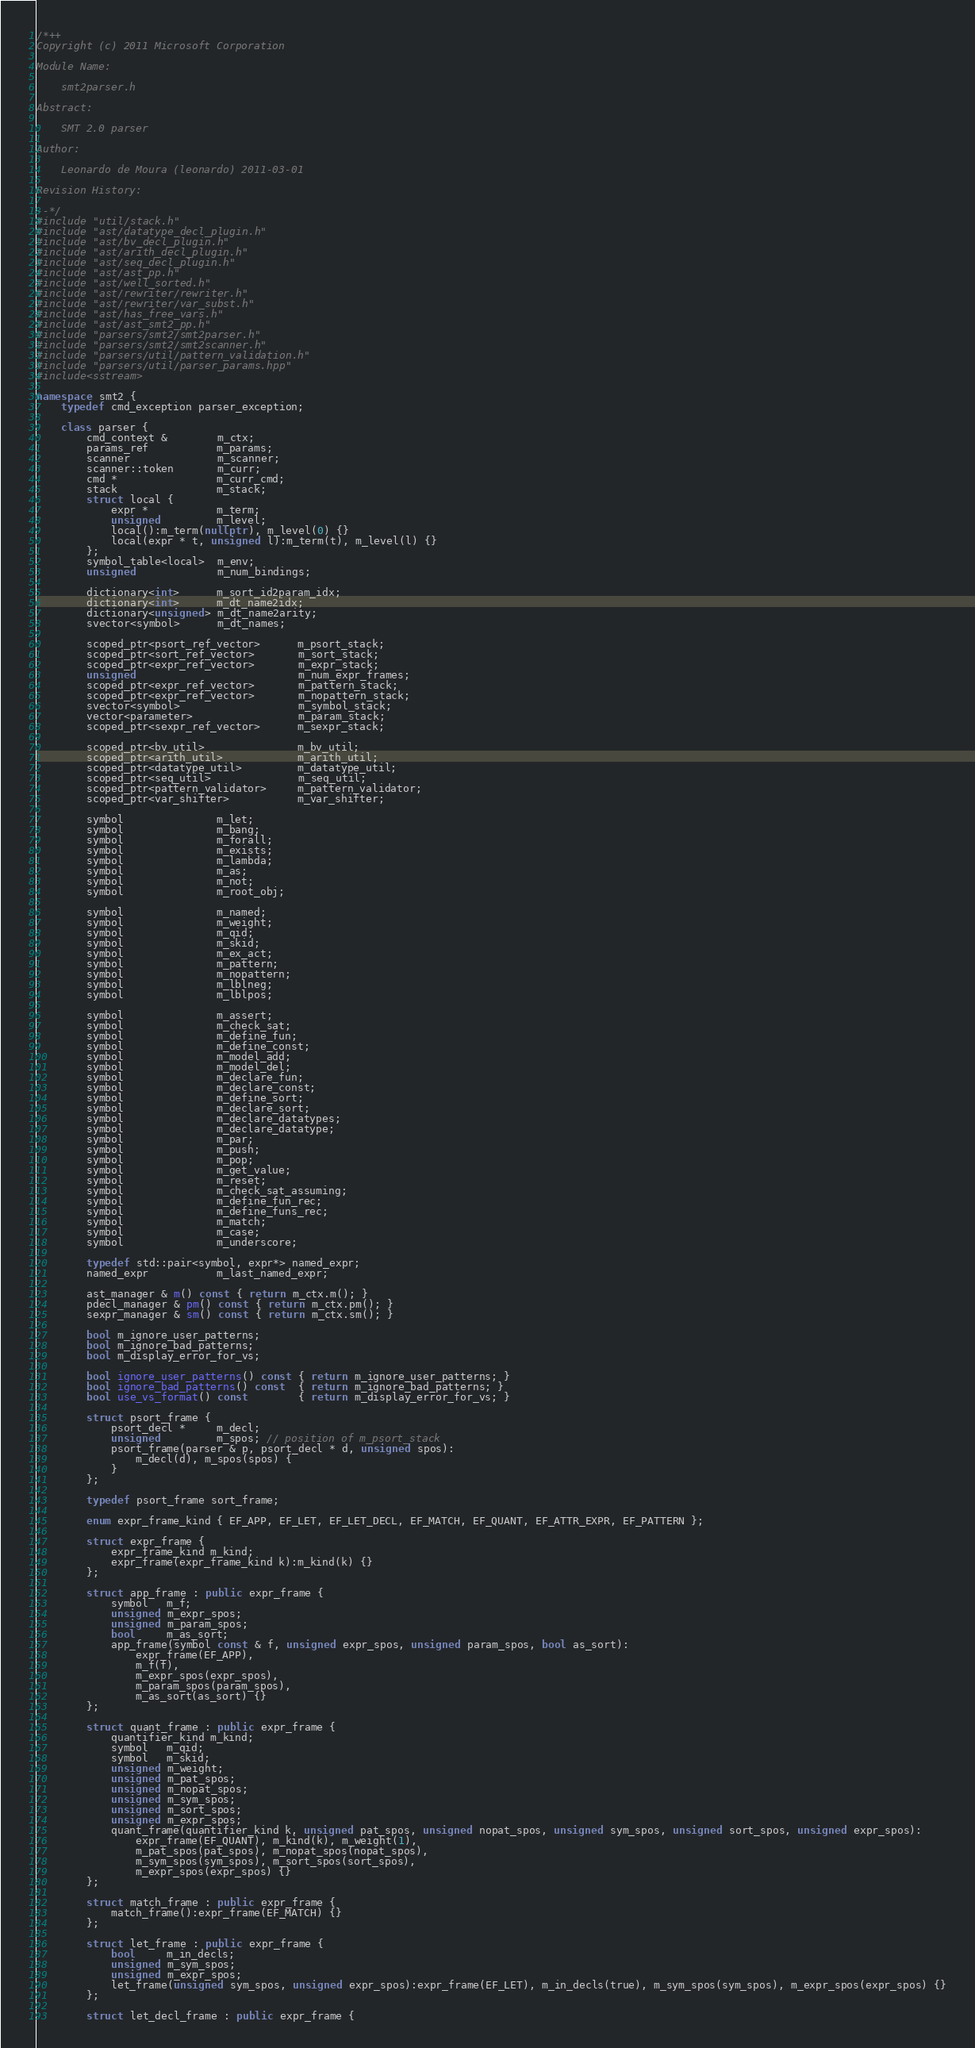Convert code to text. <code><loc_0><loc_0><loc_500><loc_500><_C++_>/*++
Copyright (c) 2011 Microsoft Corporation

Module Name:

    smt2parser.h

Abstract:

    SMT 2.0 parser

Author:

    Leonardo de Moura (leonardo) 2011-03-01

Revision History:

--*/
#include "util/stack.h"
#include "ast/datatype_decl_plugin.h"
#include "ast/bv_decl_plugin.h"
#include "ast/arith_decl_plugin.h"
#include "ast/seq_decl_plugin.h"
#include "ast/ast_pp.h"
#include "ast/well_sorted.h"
#include "ast/rewriter/rewriter.h"
#include "ast/rewriter/var_subst.h"
#include "ast/has_free_vars.h"
#include "ast/ast_smt2_pp.h"
#include "parsers/smt2/smt2parser.h"
#include "parsers/smt2/smt2scanner.h"
#include "parsers/util/pattern_validation.h"
#include "parsers/util/parser_params.hpp"
#include<sstream>

namespace smt2 {
    typedef cmd_exception parser_exception;

    class parser {
        cmd_context &        m_ctx;
        params_ref           m_params;
        scanner              m_scanner;
        scanner::token       m_curr;
        cmd *                m_curr_cmd;
        stack                m_stack;
        struct local {
            expr *           m_term;
            unsigned         m_level;
            local():m_term(nullptr), m_level(0) {}
            local(expr * t, unsigned l):m_term(t), m_level(l) {}
        };
        symbol_table<local>  m_env;
        unsigned             m_num_bindings;

        dictionary<int>      m_sort_id2param_idx;
        dictionary<int>      m_dt_name2idx;
        dictionary<unsigned> m_dt_name2arity;
        svector<symbol>      m_dt_names;

        scoped_ptr<psort_ref_vector>      m_psort_stack;
        scoped_ptr<sort_ref_vector>       m_sort_stack;
        scoped_ptr<expr_ref_vector>       m_expr_stack;
        unsigned                          m_num_expr_frames;
        scoped_ptr<expr_ref_vector>       m_pattern_stack;
        scoped_ptr<expr_ref_vector>       m_nopattern_stack;
        svector<symbol>                   m_symbol_stack;
        vector<parameter>                 m_param_stack;
        scoped_ptr<sexpr_ref_vector>      m_sexpr_stack;

        scoped_ptr<bv_util>               m_bv_util;
        scoped_ptr<arith_util>            m_arith_util;
        scoped_ptr<datatype_util>         m_datatype_util;
        scoped_ptr<seq_util>              m_seq_util;      
        scoped_ptr<pattern_validator>     m_pattern_validator;
        scoped_ptr<var_shifter>           m_var_shifter;

        symbol               m_let;
        symbol               m_bang;
        symbol               m_forall;
        symbol               m_exists;
        symbol               m_lambda;
        symbol               m_as;
        symbol               m_not;
        symbol               m_root_obj;

        symbol               m_named;
        symbol               m_weight;
        symbol               m_qid;
        symbol               m_skid;
        symbol               m_ex_act;
        symbol               m_pattern;
        symbol               m_nopattern;
        symbol               m_lblneg;
        symbol               m_lblpos;

        symbol               m_assert;
        symbol               m_check_sat;
        symbol               m_define_fun;
        symbol               m_define_const;
        symbol               m_model_add;
        symbol               m_model_del;
        symbol               m_declare_fun;
        symbol               m_declare_const;
        symbol               m_define_sort;
        symbol               m_declare_sort;
        symbol               m_declare_datatypes;
        symbol               m_declare_datatype;
        symbol               m_par;
        symbol               m_push;
        symbol               m_pop;
        symbol               m_get_value;
        symbol               m_reset;
        symbol               m_check_sat_assuming;
        symbol               m_define_fun_rec;
        symbol               m_define_funs_rec;
        symbol               m_match;
        symbol               m_case;
        symbol               m_underscore;

        typedef std::pair<symbol, expr*> named_expr;
        named_expr           m_last_named_expr;

        ast_manager & m() const { return m_ctx.m(); }
        pdecl_manager & pm() const { return m_ctx.pm(); }
        sexpr_manager & sm() const { return m_ctx.sm(); }

        bool m_ignore_user_patterns;
        bool m_ignore_bad_patterns;
        bool m_display_error_for_vs;

        bool ignore_user_patterns() const { return m_ignore_user_patterns; }
        bool ignore_bad_patterns() const  { return m_ignore_bad_patterns; }
        bool use_vs_format() const        { return m_display_error_for_vs; }

        struct psort_frame {
            psort_decl *     m_decl;
            unsigned         m_spos; // position of m_psort_stack
            psort_frame(parser & p, psort_decl * d, unsigned spos):
                m_decl(d), m_spos(spos) {
            }
        };

        typedef psort_frame sort_frame;

        enum expr_frame_kind { EF_APP, EF_LET, EF_LET_DECL, EF_MATCH, EF_QUANT, EF_ATTR_EXPR, EF_PATTERN };

        struct expr_frame {
            expr_frame_kind m_kind;
            expr_frame(expr_frame_kind k):m_kind(k) {}
        };

        struct app_frame : public expr_frame {
            symbol   m_f;
            unsigned m_expr_spos;
            unsigned m_param_spos;
            bool     m_as_sort;
            app_frame(symbol const & f, unsigned expr_spos, unsigned param_spos, bool as_sort):
                expr_frame(EF_APP),
                m_f(f),
                m_expr_spos(expr_spos),
                m_param_spos(param_spos),
                m_as_sort(as_sort) {}
        };

        struct quant_frame : public expr_frame {
            quantifier_kind m_kind;
            symbol   m_qid;
            symbol   m_skid;
            unsigned m_weight;
            unsigned m_pat_spos;
            unsigned m_nopat_spos;
            unsigned m_sym_spos;
            unsigned m_sort_spos;
            unsigned m_expr_spos;
            quant_frame(quantifier_kind k, unsigned pat_spos, unsigned nopat_spos, unsigned sym_spos, unsigned sort_spos, unsigned expr_spos):
                expr_frame(EF_QUANT), m_kind(k), m_weight(1),
                m_pat_spos(pat_spos), m_nopat_spos(nopat_spos),
                m_sym_spos(sym_spos), m_sort_spos(sort_spos),
                m_expr_spos(expr_spos) {}
        };

        struct match_frame : public expr_frame {
            match_frame():expr_frame(EF_MATCH) {}
        };

        struct let_frame : public expr_frame {
            bool     m_in_decls;
            unsigned m_sym_spos;
            unsigned m_expr_spos;
            let_frame(unsigned sym_spos, unsigned expr_spos):expr_frame(EF_LET), m_in_decls(true), m_sym_spos(sym_spos), m_expr_spos(expr_spos) {}
        };

        struct let_decl_frame : public expr_frame {</code> 